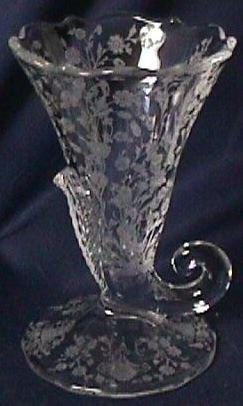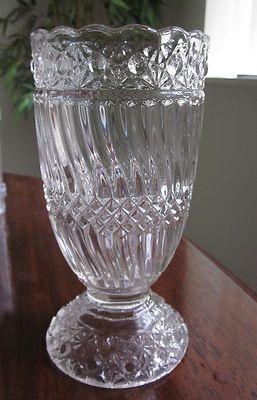The first image is the image on the left, the second image is the image on the right. Analyze the images presented: Is the assertion "An image shows a vase with a curl like an ocean wave at the bottom." valid? Answer yes or no. Yes. The first image is the image on the left, the second image is the image on the right. Considering the images on both sides, is "One of the goblets has a curled tail." valid? Answer yes or no. Yes. 